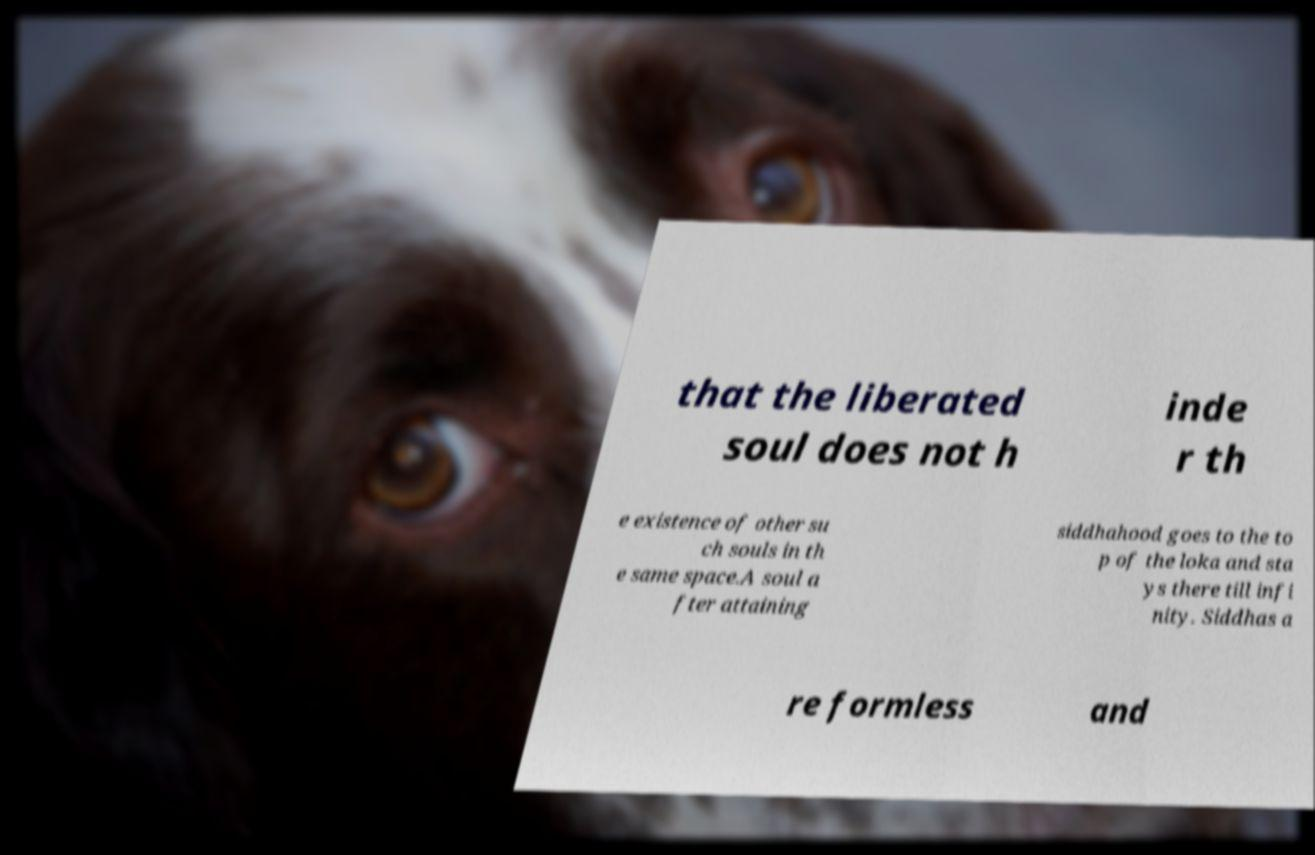Could you assist in decoding the text presented in this image and type it out clearly? that the liberated soul does not h inde r th e existence of other su ch souls in th e same space.A soul a fter attaining siddhahood goes to the to p of the loka and sta ys there till infi nity. Siddhas a re formless and 